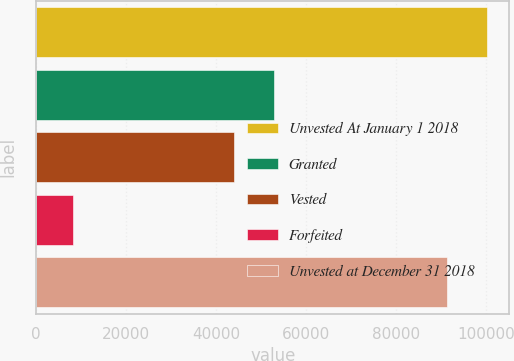<chart> <loc_0><loc_0><loc_500><loc_500><bar_chart><fcel>Unvested At January 1 2018<fcel>Granted<fcel>Vested<fcel>Forfeited<fcel>Unvested at December 31 2018<nl><fcel>100080<fcel>52830.3<fcel>43931<fcel>8105<fcel>91181<nl></chart> 